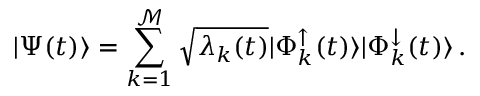Convert formula to latex. <formula><loc_0><loc_0><loc_500><loc_500>| \Psi ( t ) \rangle = \sum _ { k = 1 } ^ { \mathcal { M } } \sqrt { \lambda _ { k } ( t ) } | \Phi _ { k } ^ { \uparrow } ( t ) \rangle | \Phi _ { k } ^ { \downarrow } ( t ) \rangle \, .</formula> 